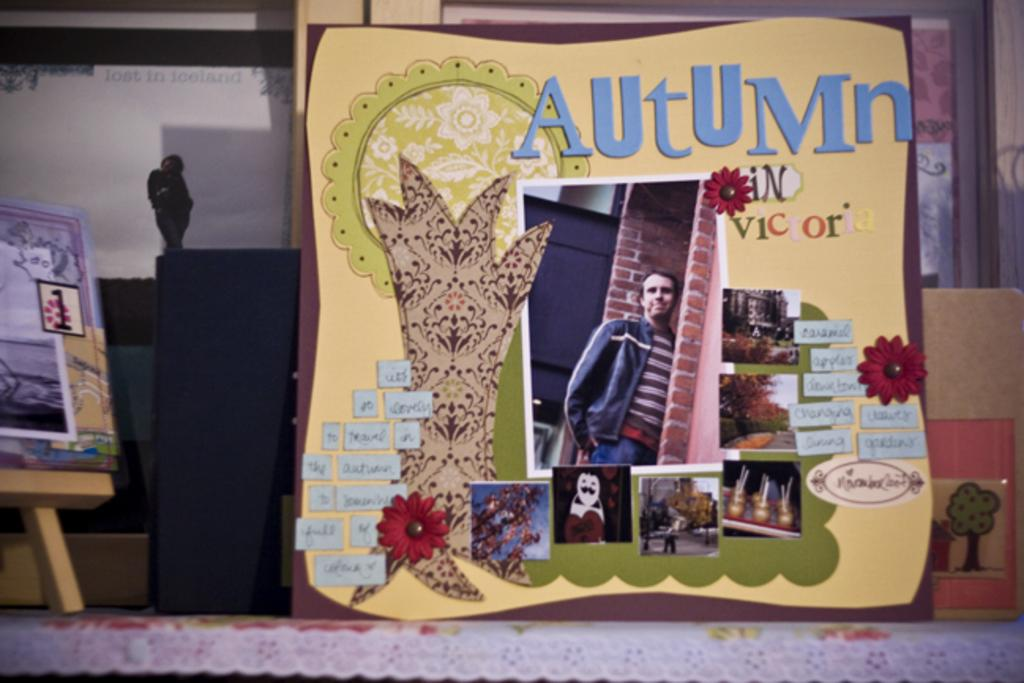<image>
Offer a succinct explanation of the picture presented. The season advertised in the card is Autumn. 